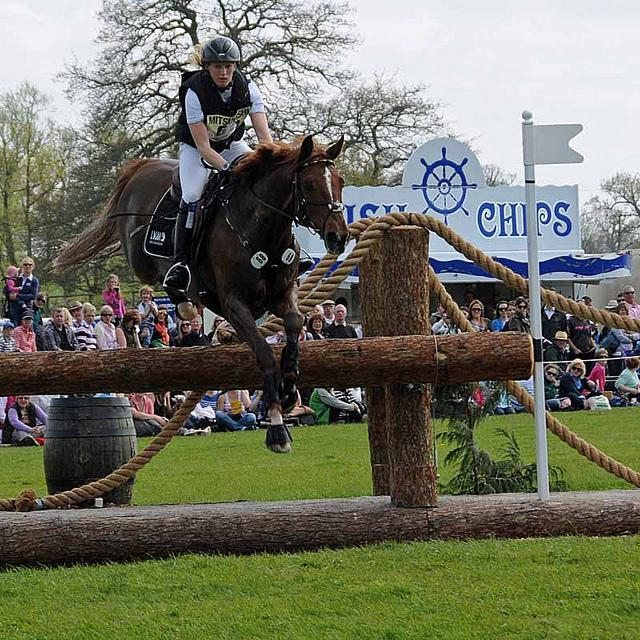What object is in the center of the chips stand logo? steering wheel 